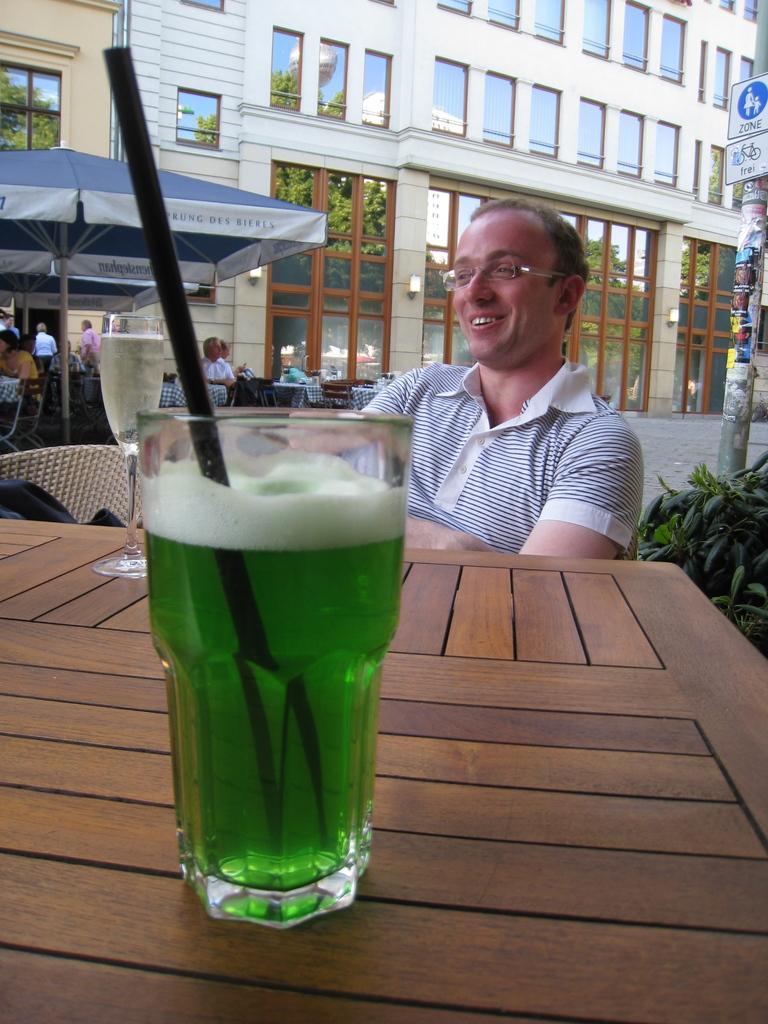In one or two sentences, can you explain what this image depicts? In this image I can see a glass on the table, in the glass I can see some liquid in green color and the table is in brown color. Background I can see a person sitting wearing white color shirt, I can also see a tent in blue and white color, few other persons sitting and background the building is in white color. 